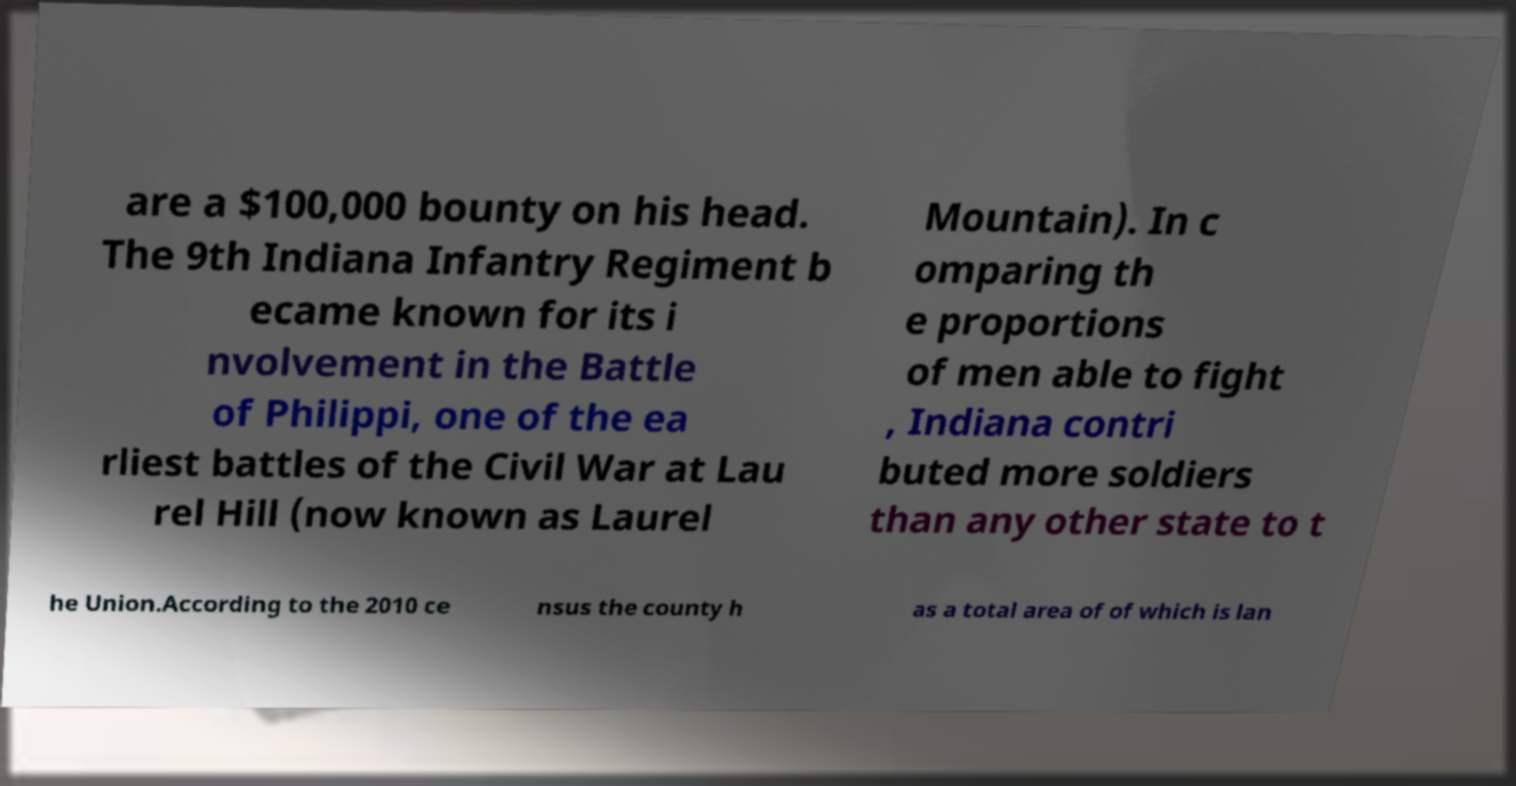Can you read and provide the text displayed in the image?This photo seems to have some interesting text. Can you extract and type it out for me? are a $100,000 bounty on his head. The 9th Indiana Infantry Regiment b ecame known for its i nvolvement in the Battle of Philippi, one of the ea rliest battles of the Civil War at Lau rel Hill (now known as Laurel Mountain). In c omparing th e proportions of men able to fight , Indiana contri buted more soldiers than any other state to t he Union.According to the 2010 ce nsus the county h as a total area of of which is lan 